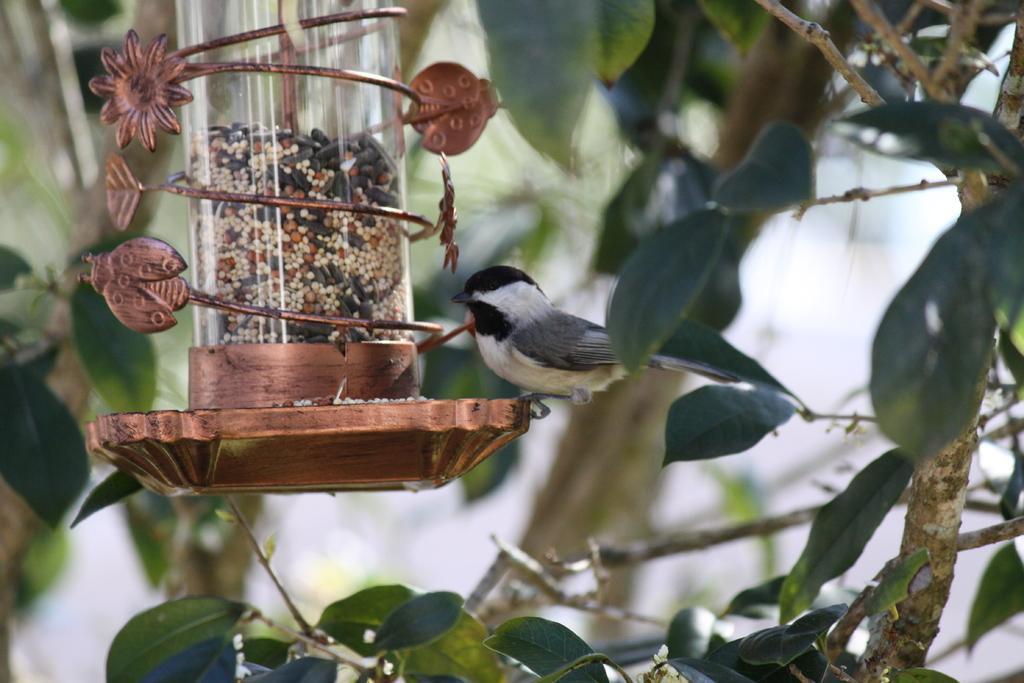What type of animal can be seen in the image? There is a bird in the image. Where is the bird located in the image? The bird is sitting on a bird feeder. On which side of the image is the bird feeder? The bird feeder is on the left side of the image. What can be seen in the background of the image? There is a stem with leaves in the background of the image. What type of dress is the bird wearing in the image? Birds do not wear dresses, so there is no dress present in the image. 